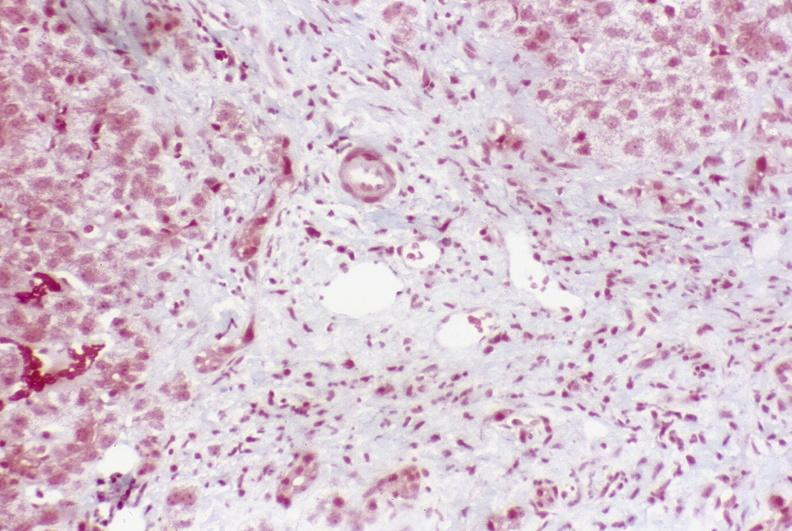what is present?
Answer the question using a single word or phrase. Liver 